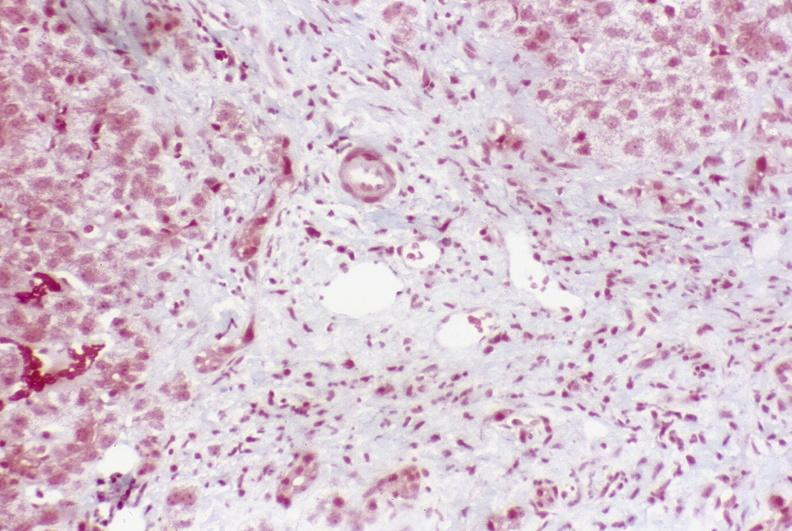what is present?
Answer the question using a single word or phrase. Liver 